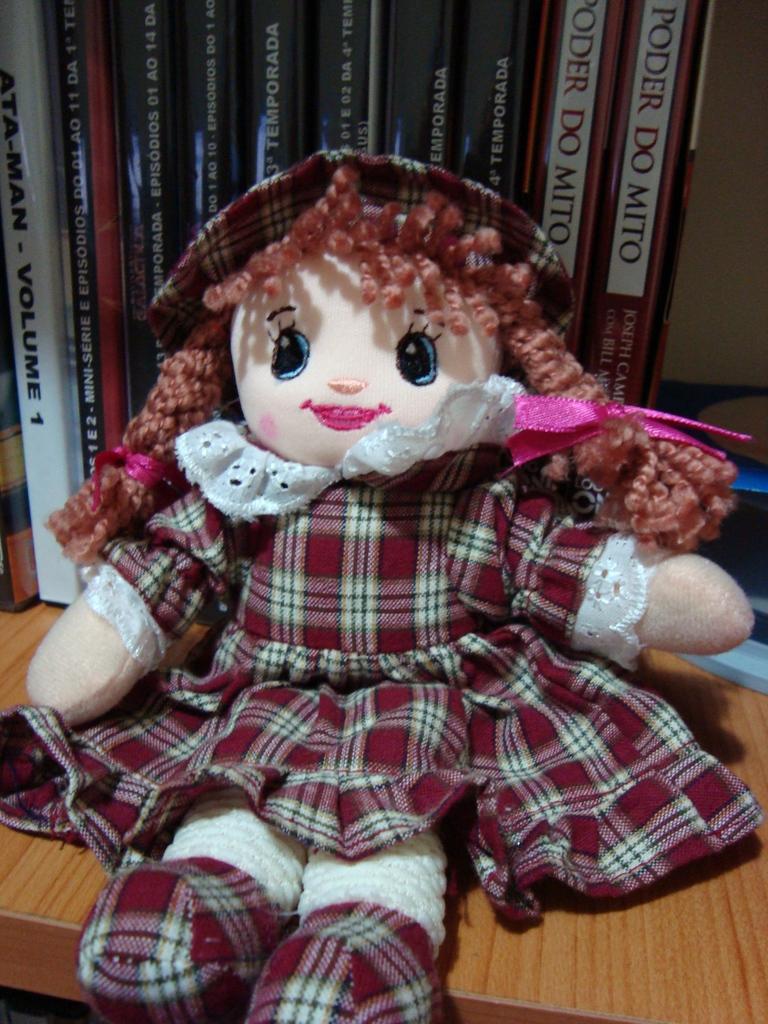Please provide a concise description of this image. In this picture we can observe a doll which is in cream color. There is a maroon color frock on the doll. We can observe a cap on the head of this doll. The doll is placed on the brown color table. Behind the doll there are some books. 